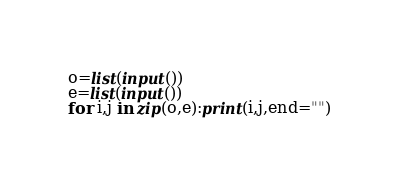<code> <loc_0><loc_0><loc_500><loc_500><_Python_>o=list(input())
e=list(input())
for i,j in zip(o,e):print(i,j,end="")</code> 